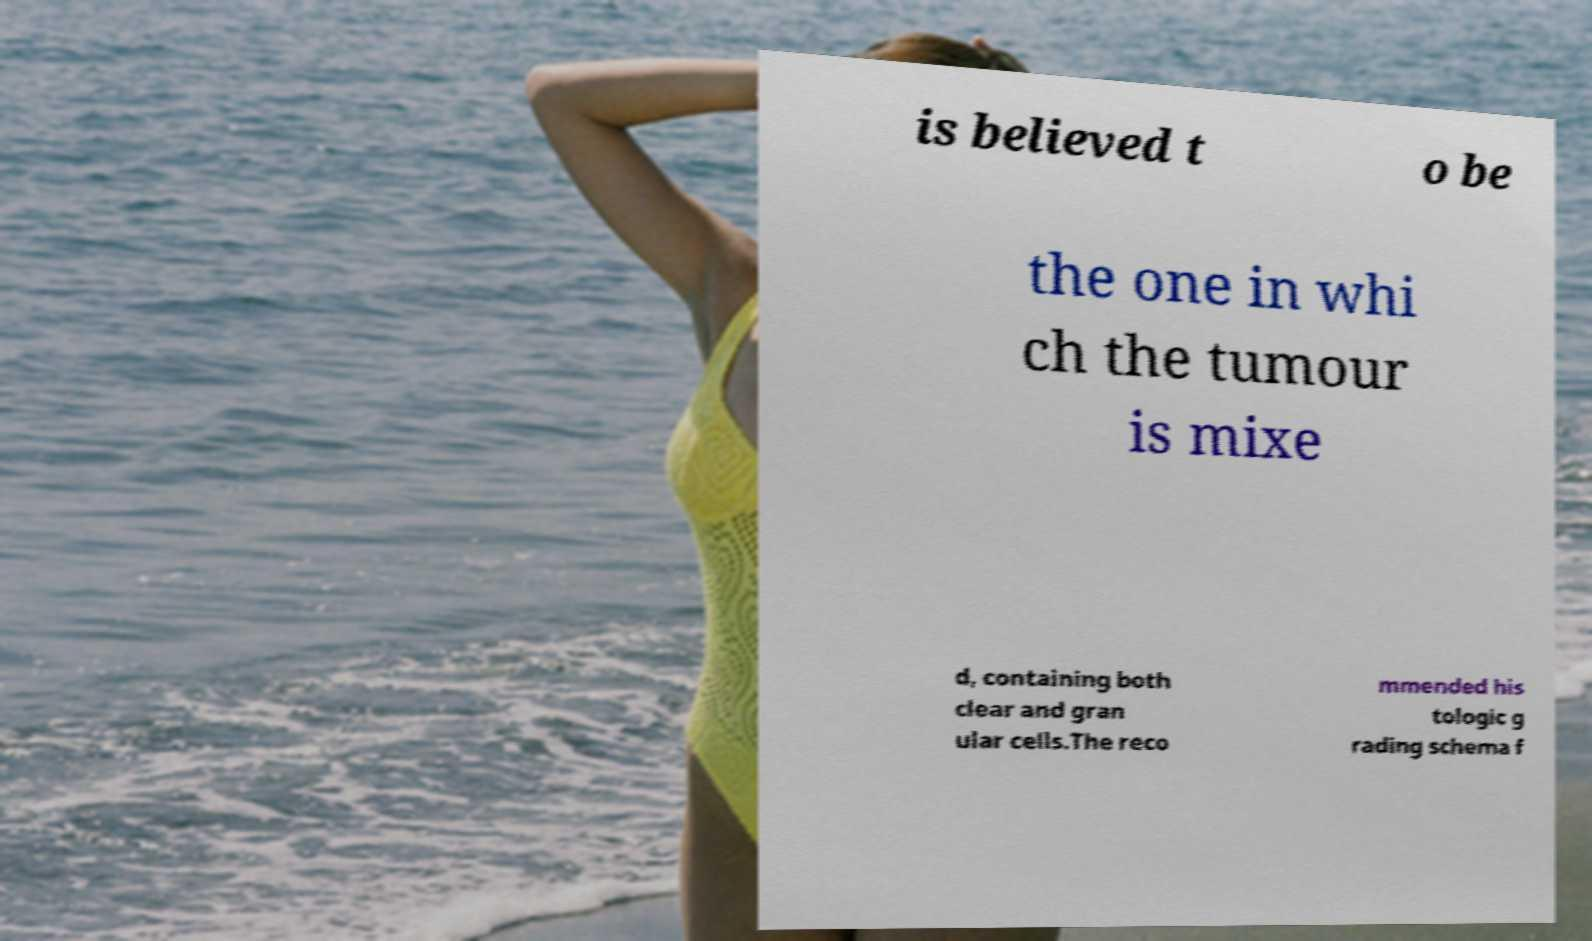What messages or text are displayed in this image? I need them in a readable, typed format. is believed t o be the one in whi ch the tumour is mixe d, containing both clear and gran ular cells.The reco mmended his tologic g rading schema f 